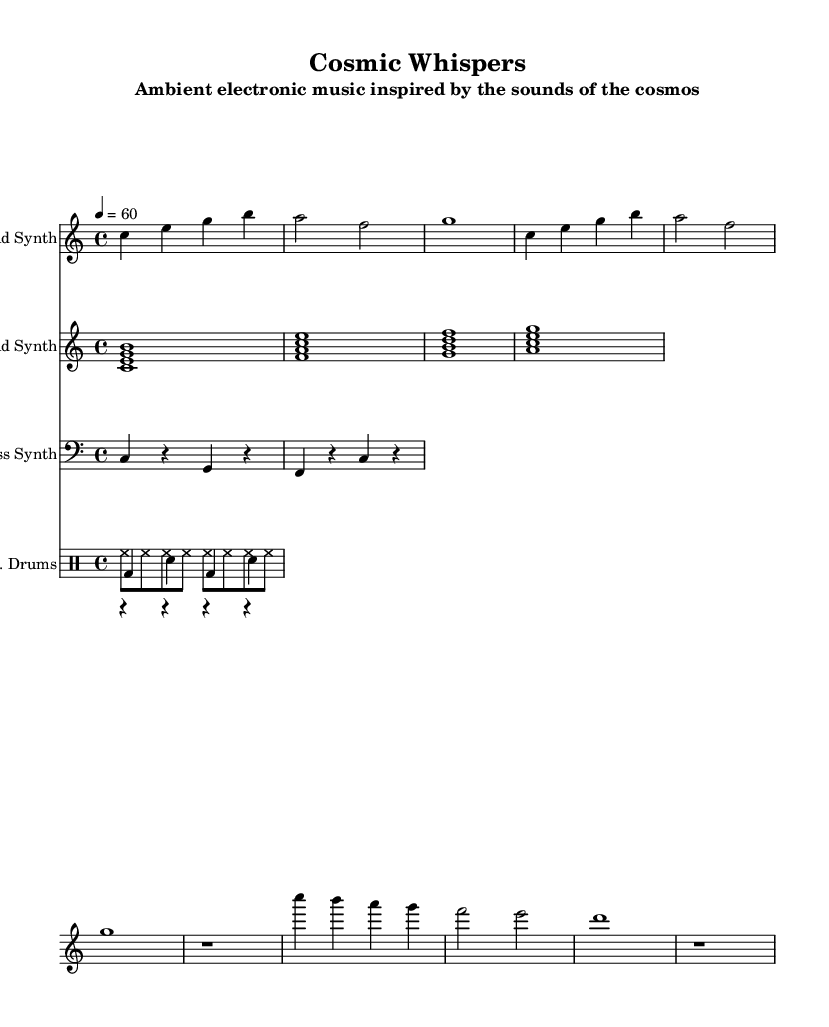What is the key signature of this music? The key signature is indicated at the beginning of the score, which shows C major, characterized by having no sharps or flats.
Answer: C major What is the time signature of this piece? The time signature is found at the start of the music; it shows 4/4, meaning there are four beats per measure with a quarter note getting one beat.
Answer: 4/4 What is the tempo marking of the music? The tempo is indicated in beats per minute, which in this case is marked as 60, meaning the beats should be played at one per second.
Answer: 60 How many measures are in the lead synth part? By counting the measures in the lead synth staff, each grouping between the vertical lines indicates a measure. There are 10 measures indicated in the lead synth part.
Answer: 10 What chords are used in the pad synth part? The pad synth part features a chord progression with the following chords: C major, F major, G major, and A minor. These chords are typically made of the root and other scale degrees.
Answer: C, F, G, A What rhythm is used in the kick drum pattern? The kick drum pattern consists of a bass drum played on the first and third beats (bd) with rests in between, indicating a simple rhythm following the 4/4 time signature.
Answer: bass drum on first and third beats What is the primary sound source of the music? The primary sound source is synthesized, indicated by the naming of the parts such as "Lead Synth," "Pad Synth," and "Bass Synth," alluding to electronic music production techniques.
Answer: Synthesized sounds 